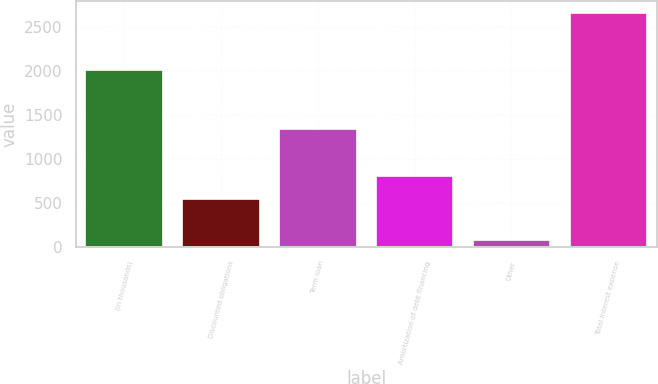<chart> <loc_0><loc_0><loc_500><loc_500><bar_chart><fcel>(in thousands)<fcel>Discounted obligations<fcel>Term loan<fcel>Amortization of debt financing<fcel>Other<fcel>Total interest expense<nl><fcel>2012<fcel>546<fcel>1342<fcel>804.6<fcel>75<fcel>2661<nl></chart> 